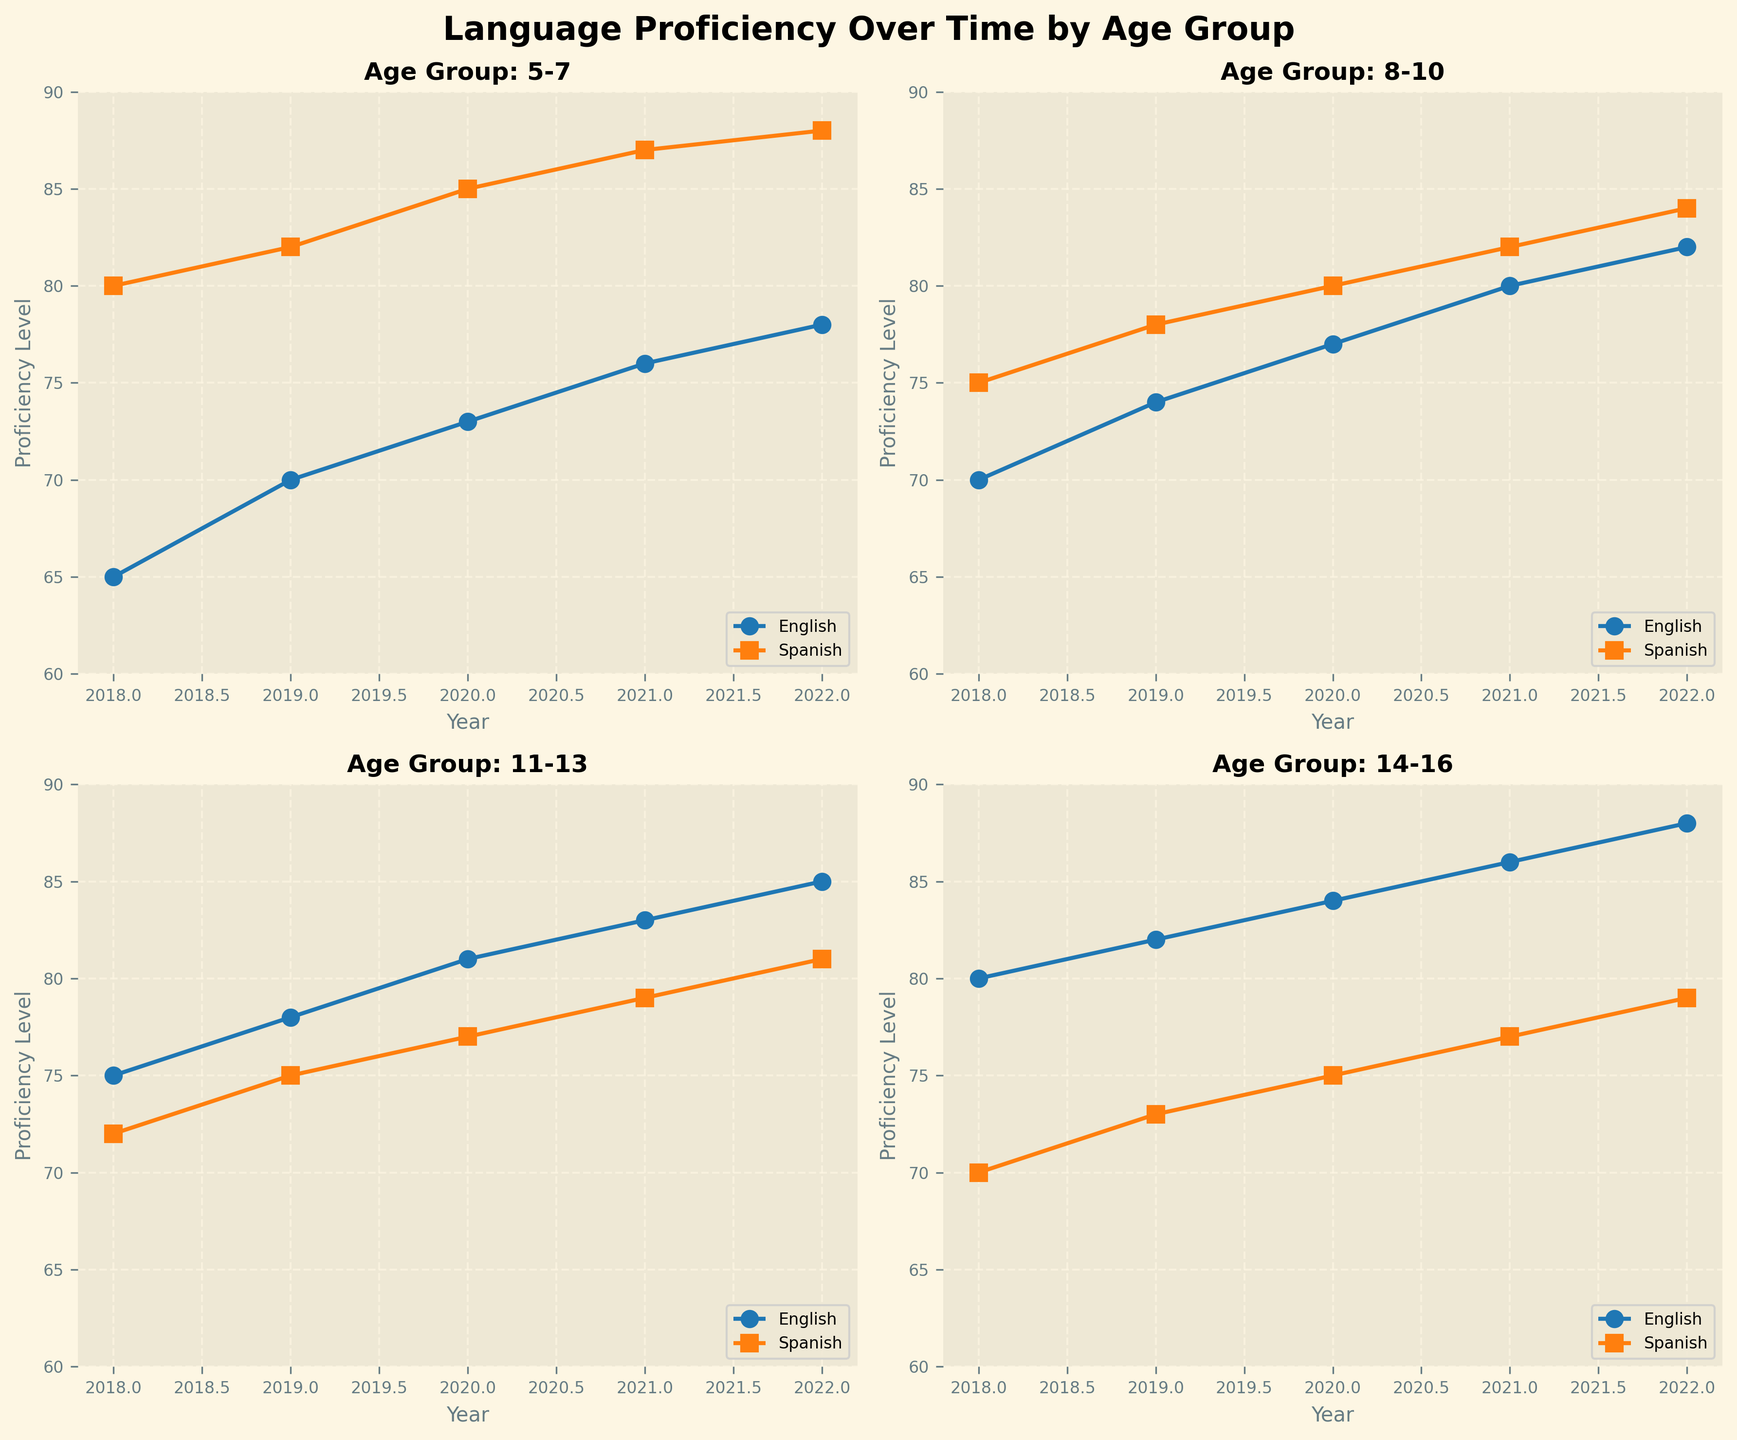What's the title of the figure? Look at the large text at the top of the figure, which provides the title.
Answer: Language Proficiency Over Time by Age Group What are the two languages tracked in the plot? Check the labels in the legend provided in each subplot to identify the languages.
Answer: English and Spanish Which age group shows the highest English proficiency level in 2022? Compare the highest English proficiency levels for each age group for the year 2022. The highest proficiency level for English is 88 in the 14-16 age group.
Answer: 14-16 How does Spanish proficiency change over time for the 5-7 age group? Observe the Spanish proficiency line in the subplot for the 5-7 age group and note the trend from 2018 to 2022.
Answer: It increases Which age group shows a greater increase in English proficiency from 2018 to 2022? Calculate the difference in English proficiency from 2018 to 2022 for each age group and compare the values.
Answer: 14-16 What age group had nearly the same proficiency level in both languages in 2018? Look at the plots for each age group in 2018 and find the group where English and Spanish proficiency levels are closest. For the 8-10 age group in 2018, the English proficiency is 70 and the Spanish proficiency is 75.
Answer: 8-10 In 2020, which age group had a higher Spanish proficiency: 8-10 or 11-13? Compare the Spanish proficiency values for the 8-10 and 11-13 age groups in the year 2020.
Answer: 8-10 Which year did the 11-13 age group's English proficiency surpass 80? Observe the English proficiency line for the 11-13 age group and identify the first year it exceeds 80.
Answer: 2020 How close were the English and Spanish proficiency scores for the 14-16 age group in 2022? Check the English and Spanish proficiency values in 2022 for the 14-16 age group and find the difference between them (88 - 79 = 9).
Answer: 9 points Is the trend of the English proficiency for the 8-10 age group increasing, decreasing, or stable? Look at the English proficiency line for the 8-10 age group over the years to determine the trend.
Answer: Increasing 